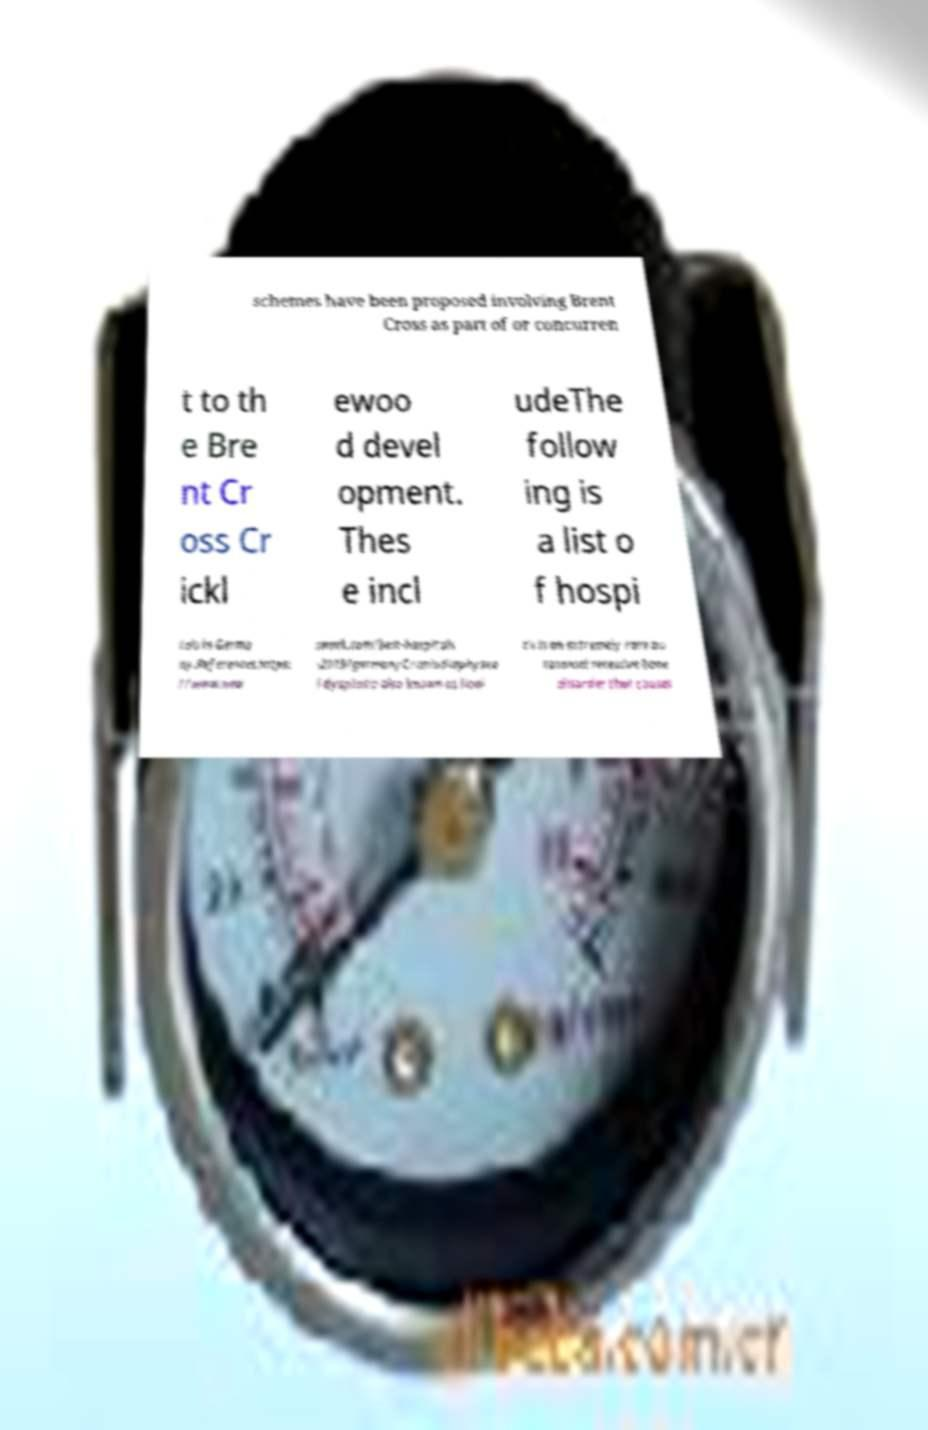Please read and relay the text visible in this image. What does it say? schemes have been proposed involving Brent Cross as part of or concurren t to th e Bre nt Cr oss Cr ickl ewoo d devel opment. Thes e incl udeThe follow ing is a list o f hospi tals in Germa ny.References.https: //www.new sweek.com/best-hospitals -2019/germanyCraniodiaphysea l dysplasia also known as lioni tis is an extremely rare au tosomal recessive bone disorder that causes 